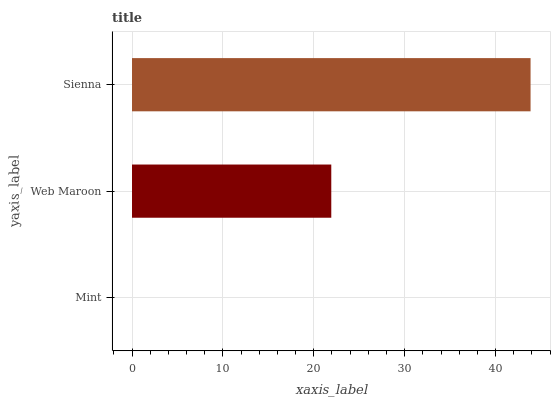Is Mint the minimum?
Answer yes or no. Yes. Is Sienna the maximum?
Answer yes or no. Yes. Is Web Maroon the minimum?
Answer yes or no. No. Is Web Maroon the maximum?
Answer yes or no. No. Is Web Maroon greater than Mint?
Answer yes or no. Yes. Is Mint less than Web Maroon?
Answer yes or no. Yes. Is Mint greater than Web Maroon?
Answer yes or no. No. Is Web Maroon less than Mint?
Answer yes or no. No. Is Web Maroon the high median?
Answer yes or no. Yes. Is Web Maroon the low median?
Answer yes or no. Yes. Is Sienna the high median?
Answer yes or no. No. Is Mint the low median?
Answer yes or no. No. 